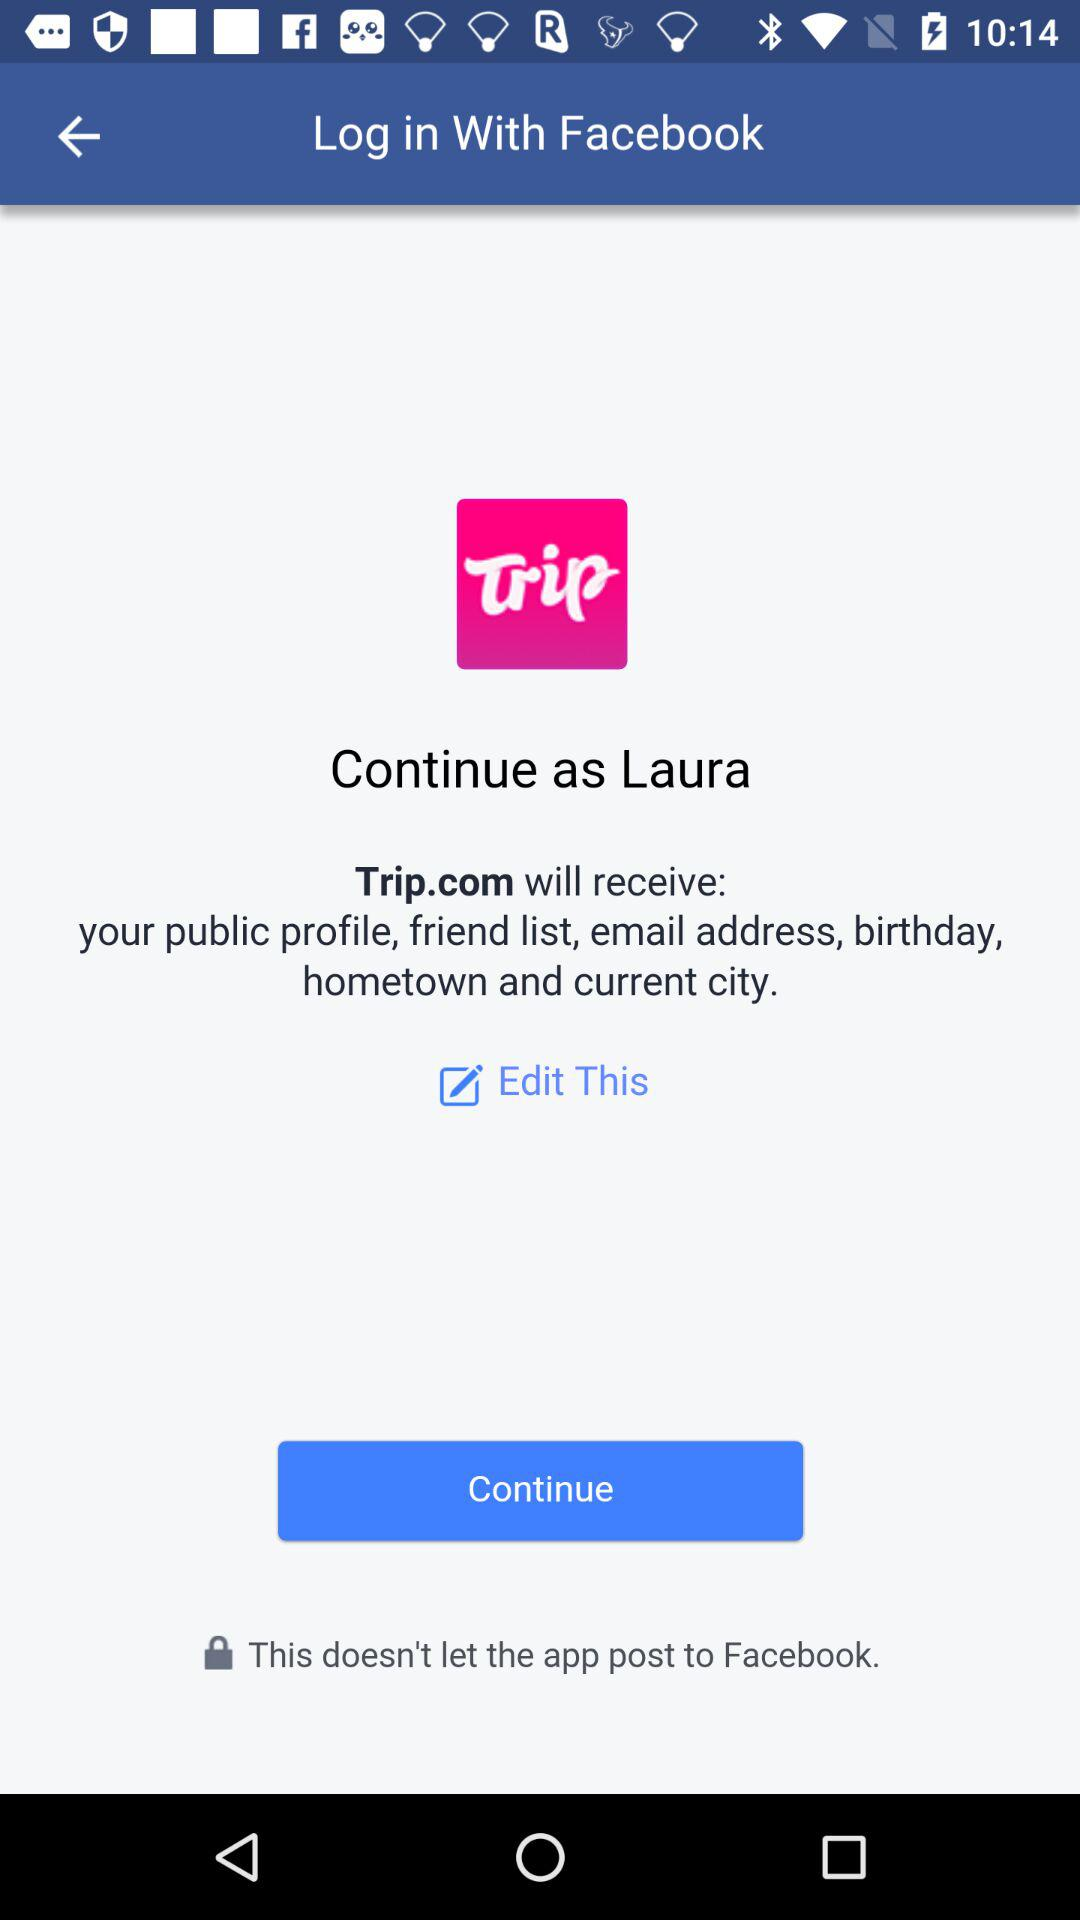What application can be used to log in? The application that can be used to log in is "Facebook". 